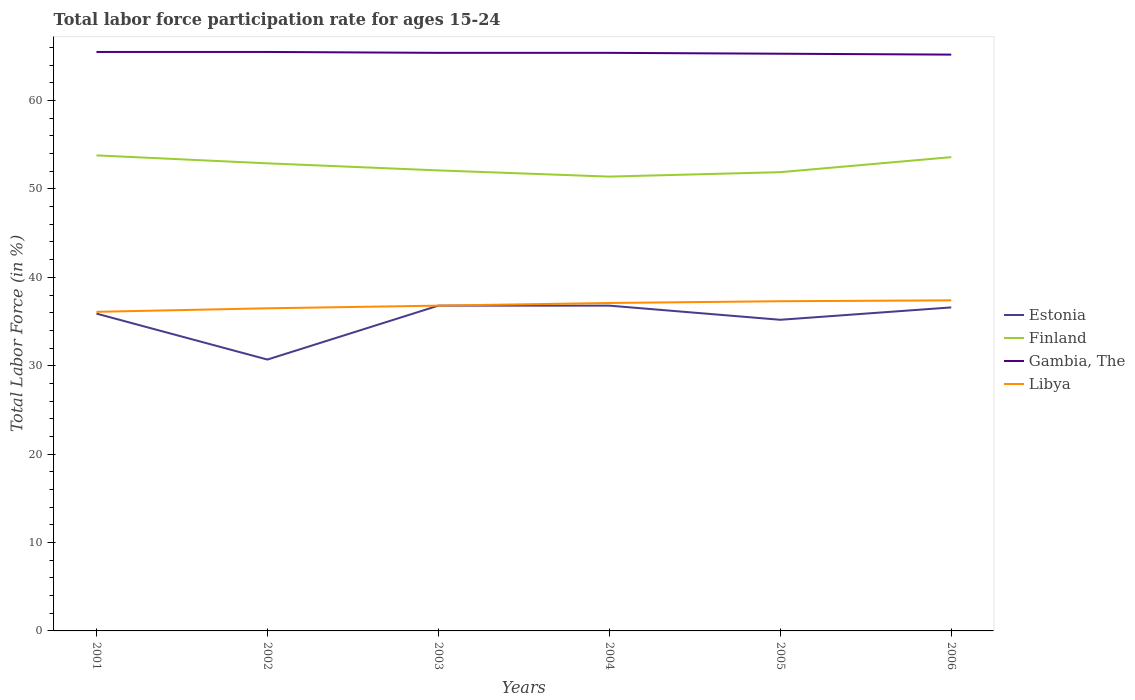Across all years, what is the maximum labor force participation rate in Finland?
Keep it short and to the point. 51.4. What is the total labor force participation rate in Libya in the graph?
Make the answer very short. -1.3. What is the difference between the highest and the second highest labor force participation rate in Estonia?
Give a very brief answer. 6.1. Is the labor force participation rate in Gambia, The strictly greater than the labor force participation rate in Libya over the years?
Your answer should be compact. No. What is the difference between two consecutive major ticks on the Y-axis?
Offer a very short reply. 10. Are the values on the major ticks of Y-axis written in scientific E-notation?
Make the answer very short. No. Does the graph contain grids?
Provide a short and direct response. No. How many legend labels are there?
Provide a short and direct response. 4. What is the title of the graph?
Offer a very short reply. Total labor force participation rate for ages 15-24. Does "Belarus" appear as one of the legend labels in the graph?
Provide a succinct answer. No. What is the label or title of the X-axis?
Your response must be concise. Years. What is the Total Labor Force (in %) in Estonia in 2001?
Provide a short and direct response. 35.9. What is the Total Labor Force (in %) of Finland in 2001?
Your answer should be compact. 53.8. What is the Total Labor Force (in %) of Gambia, The in 2001?
Your answer should be very brief. 65.5. What is the Total Labor Force (in %) of Libya in 2001?
Keep it short and to the point. 36.1. What is the Total Labor Force (in %) in Estonia in 2002?
Give a very brief answer. 30.7. What is the Total Labor Force (in %) in Finland in 2002?
Offer a terse response. 52.9. What is the Total Labor Force (in %) of Gambia, The in 2002?
Offer a very short reply. 65.5. What is the Total Labor Force (in %) of Libya in 2002?
Offer a terse response. 36.5. What is the Total Labor Force (in %) of Estonia in 2003?
Your answer should be compact. 36.8. What is the Total Labor Force (in %) of Finland in 2003?
Provide a short and direct response. 52.1. What is the Total Labor Force (in %) in Gambia, The in 2003?
Make the answer very short. 65.4. What is the Total Labor Force (in %) of Libya in 2003?
Ensure brevity in your answer.  36.8. What is the Total Labor Force (in %) of Estonia in 2004?
Your answer should be compact. 36.8. What is the Total Labor Force (in %) in Finland in 2004?
Provide a short and direct response. 51.4. What is the Total Labor Force (in %) in Gambia, The in 2004?
Ensure brevity in your answer.  65.4. What is the Total Labor Force (in %) in Libya in 2004?
Offer a very short reply. 37.1. What is the Total Labor Force (in %) of Estonia in 2005?
Your answer should be very brief. 35.2. What is the Total Labor Force (in %) of Finland in 2005?
Your answer should be very brief. 51.9. What is the Total Labor Force (in %) in Gambia, The in 2005?
Offer a very short reply. 65.3. What is the Total Labor Force (in %) of Libya in 2005?
Your response must be concise. 37.3. What is the Total Labor Force (in %) of Estonia in 2006?
Give a very brief answer. 36.6. What is the Total Labor Force (in %) in Finland in 2006?
Provide a short and direct response. 53.6. What is the Total Labor Force (in %) of Gambia, The in 2006?
Offer a terse response. 65.2. What is the Total Labor Force (in %) in Libya in 2006?
Provide a short and direct response. 37.4. Across all years, what is the maximum Total Labor Force (in %) of Estonia?
Your answer should be compact. 36.8. Across all years, what is the maximum Total Labor Force (in %) of Finland?
Offer a terse response. 53.8. Across all years, what is the maximum Total Labor Force (in %) in Gambia, The?
Your response must be concise. 65.5. Across all years, what is the maximum Total Labor Force (in %) in Libya?
Ensure brevity in your answer.  37.4. Across all years, what is the minimum Total Labor Force (in %) of Estonia?
Provide a short and direct response. 30.7. Across all years, what is the minimum Total Labor Force (in %) in Finland?
Your response must be concise. 51.4. Across all years, what is the minimum Total Labor Force (in %) in Gambia, The?
Provide a short and direct response. 65.2. Across all years, what is the minimum Total Labor Force (in %) in Libya?
Your response must be concise. 36.1. What is the total Total Labor Force (in %) in Estonia in the graph?
Give a very brief answer. 212. What is the total Total Labor Force (in %) of Finland in the graph?
Offer a terse response. 315.7. What is the total Total Labor Force (in %) in Gambia, The in the graph?
Offer a very short reply. 392.3. What is the total Total Labor Force (in %) in Libya in the graph?
Ensure brevity in your answer.  221.2. What is the difference between the Total Labor Force (in %) in Finland in 2001 and that in 2002?
Give a very brief answer. 0.9. What is the difference between the Total Labor Force (in %) in Libya in 2001 and that in 2003?
Keep it short and to the point. -0.7. What is the difference between the Total Labor Force (in %) in Finland in 2001 and that in 2004?
Offer a very short reply. 2.4. What is the difference between the Total Labor Force (in %) in Gambia, The in 2001 and that in 2004?
Ensure brevity in your answer.  0.1. What is the difference between the Total Labor Force (in %) in Estonia in 2001 and that in 2005?
Provide a succinct answer. 0.7. What is the difference between the Total Labor Force (in %) in Libya in 2001 and that in 2005?
Keep it short and to the point. -1.2. What is the difference between the Total Labor Force (in %) of Estonia in 2001 and that in 2006?
Your answer should be very brief. -0.7. What is the difference between the Total Labor Force (in %) in Gambia, The in 2001 and that in 2006?
Your answer should be very brief. 0.3. What is the difference between the Total Labor Force (in %) of Libya in 2001 and that in 2006?
Your answer should be compact. -1.3. What is the difference between the Total Labor Force (in %) in Estonia in 2002 and that in 2005?
Your answer should be very brief. -4.5. What is the difference between the Total Labor Force (in %) of Gambia, The in 2002 and that in 2005?
Your answer should be compact. 0.2. What is the difference between the Total Labor Force (in %) in Finland in 2002 and that in 2006?
Provide a succinct answer. -0.7. What is the difference between the Total Labor Force (in %) in Gambia, The in 2002 and that in 2006?
Keep it short and to the point. 0.3. What is the difference between the Total Labor Force (in %) in Gambia, The in 2003 and that in 2004?
Make the answer very short. 0. What is the difference between the Total Labor Force (in %) in Libya in 2003 and that in 2004?
Your response must be concise. -0.3. What is the difference between the Total Labor Force (in %) in Libya in 2003 and that in 2005?
Offer a terse response. -0.5. What is the difference between the Total Labor Force (in %) in Finland in 2003 and that in 2006?
Make the answer very short. -1.5. What is the difference between the Total Labor Force (in %) of Finland in 2004 and that in 2005?
Provide a short and direct response. -0.5. What is the difference between the Total Labor Force (in %) in Libya in 2004 and that in 2005?
Your answer should be very brief. -0.2. What is the difference between the Total Labor Force (in %) in Libya in 2004 and that in 2006?
Offer a very short reply. -0.3. What is the difference between the Total Labor Force (in %) in Estonia in 2005 and that in 2006?
Provide a succinct answer. -1.4. What is the difference between the Total Labor Force (in %) in Finland in 2005 and that in 2006?
Give a very brief answer. -1.7. What is the difference between the Total Labor Force (in %) of Gambia, The in 2005 and that in 2006?
Give a very brief answer. 0.1. What is the difference between the Total Labor Force (in %) of Libya in 2005 and that in 2006?
Your answer should be very brief. -0.1. What is the difference between the Total Labor Force (in %) in Estonia in 2001 and the Total Labor Force (in %) in Finland in 2002?
Keep it short and to the point. -17. What is the difference between the Total Labor Force (in %) of Estonia in 2001 and the Total Labor Force (in %) of Gambia, The in 2002?
Give a very brief answer. -29.6. What is the difference between the Total Labor Force (in %) in Estonia in 2001 and the Total Labor Force (in %) in Libya in 2002?
Keep it short and to the point. -0.6. What is the difference between the Total Labor Force (in %) of Estonia in 2001 and the Total Labor Force (in %) of Finland in 2003?
Keep it short and to the point. -16.2. What is the difference between the Total Labor Force (in %) of Estonia in 2001 and the Total Labor Force (in %) of Gambia, The in 2003?
Your answer should be very brief. -29.5. What is the difference between the Total Labor Force (in %) in Estonia in 2001 and the Total Labor Force (in %) in Libya in 2003?
Provide a succinct answer. -0.9. What is the difference between the Total Labor Force (in %) in Finland in 2001 and the Total Labor Force (in %) in Libya in 2003?
Offer a terse response. 17. What is the difference between the Total Labor Force (in %) in Gambia, The in 2001 and the Total Labor Force (in %) in Libya in 2003?
Provide a succinct answer. 28.7. What is the difference between the Total Labor Force (in %) in Estonia in 2001 and the Total Labor Force (in %) in Finland in 2004?
Provide a succinct answer. -15.5. What is the difference between the Total Labor Force (in %) of Estonia in 2001 and the Total Labor Force (in %) of Gambia, The in 2004?
Provide a short and direct response. -29.5. What is the difference between the Total Labor Force (in %) of Estonia in 2001 and the Total Labor Force (in %) of Libya in 2004?
Give a very brief answer. -1.2. What is the difference between the Total Labor Force (in %) of Finland in 2001 and the Total Labor Force (in %) of Gambia, The in 2004?
Keep it short and to the point. -11.6. What is the difference between the Total Labor Force (in %) in Gambia, The in 2001 and the Total Labor Force (in %) in Libya in 2004?
Your response must be concise. 28.4. What is the difference between the Total Labor Force (in %) of Estonia in 2001 and the Total Labor Force (in %) of Finland in 2005?
Make the answer very short. -16. What is the difference between the Total Labor Force (in %) of Estonia in 2001 and the Total Labor Force (in %) of Gambia, The in 2005?
Make the answer very short. -29.4. What is the difference between the Total Labor Force (in %) of Finland in 2001 and the Total Labor Force (in %) of Gambia, The in 2005?
Ensure brevity in your answer.  -11.5. What is the difference between the Total Labor Force (in %) in Gambia, The in 2001 and the Total Labor Force (in %) in Libya in 2005?
Offer a very short reply. 28.2. What is the difference between the Total Labor Force (in %) in Estonia in 2001 and the Total Labor Force (in %) in Finland in 2006?
Provide a succinct answer. -17.7. What is the difference between the Total Labor Force (in %) of Estonia in 2001 and the Total Labor Force (in %) of Gambia, The in 2006?
Provide a succinct answer. -29.3. What is the difference between the Total Labor Force (in %) in Gambia, The in 2001 and the Total Labor Force (in %) in Libya in 2006?
Your answer should be very brief. 28.1. What is the difference between the Total Labor Force (in %) of Estonia in 2002 and the Total Labor Force (in %) of Finland in 2003?
Give a very brief answer. -21.4. What is the difference between the Total Labor Force (in %) in Estonia in 2002 and the Total Labor Force (in %) in Gambia, The in 2003?
Your answer should be very brief. -34.7. What is the difference between the Total Labor Force (in %) of Finland in 2002 and the Total Labor Force (in %) of Gambia, The in 2003?
Your response must be concise. -12.5. What is the difference between the Total Labor Force (in %) in Gambia, The in 2002 and the Total Labor Force (in %) in Libya in 2003?
Provide a succinct answer. 28.7. What is the difference between the Total Labor Force (in %) in Estonia in 2002 and the Total Labor Force (in %) in Finland in 2004?
Make the answer very short. -20.7. What is the difference between the Total Labor Force (in %) of Estonia in 2002 and the Total Labor Force (in %) of Gambia, The in 2004?
Make the answer very short. -34.7. What is the difference between the Total Labor Force (in %) in Gambia, The in 2002 and the Total Labor Force (in %) in Libya in 2004?
Provide a succinct answer. 28.4. What is the difference between the Total Labor Force (in %) in Estonia in 2002 and the Total Labor Force (in %) in Finland in 2005?
Make the answer very short. -21.2. What is the difference between the Total Labor Force (in %) of Estonia in 2002 and the Total Labor Force (in %) of Gambia, The in 2005?
Provide a succinct answer. -34.6. What is the difference between the Total Labor Force (in %) in Estonia in 2002 and the Total Labor Force (in %) in Libya in 2005?
Keep it short and to the point. -6.6. What is the difference between the Total Labor Force (in %) in Gambia, The in 2002 and the Total Labor Force (in %) in Libya in 2005?
Offer a terse response. 28.2. What is the difference between the Total Labor Force (in %) of Estonia in 2002 and the Total Labor Force (in %) of Finland in 2006?
Ensure brevity in your answer.  -22.9. What is the difference between the Total Labor Force (in %) of Estonia in 2002 and the Total Labor Force (in %) of Gambia, The in 2006?
Provide a succinct answer. -34.5. What is the difference between the Total Labor Force (in %) of Finland in 2002 and the Total Labor Force (in %) of Gambia, The in 2006?
Your answer should be compact. -12.3. What is the difference between the Total Labor Force (in %) in Gambia, The in 2002 and the Total Labor Force (in %) in Libya in 2006?
Ensure brevity in your answer.  28.1. What is the difference between the Total Labor Force (in %) in Estonia in 2003 and the Total Labor Force (in %) in Finland in 2004?
Offer a terse response. -14.6. What is the difference between the Total Labor Force (in %) in Estonia in 2003 and the Total Labor Force (in %) in Gambia, The in 2004?
Provide a succinct answer. -28.6. What is the difference between the Total Labor Force (in %) of Finland in 2003 and the Total Labor Force (in %) of Libya in 2004?
Ensure brevity in your answer.  15. What is the difference between the Total Labor Force (in %) of Gambia, The in 2003 and the Total Labor Force (in %) of Libya in 2004?
Offer a very short reply. 28.3. What is the difference between the Total Labor Force (in %) of Estonia in 2003 and the Total Labor Force (in %) of Finland in 2005?
Offer a very short reply. -15.1. What is the difference between the Total Labor Force (in %) of Estonia in 2003 and the Total Labor Force (in %) of Gambia, The in 2005?
Your answer should be compact. -28.5. What is the difference between the Total Labor Force (in %) of Estonia in 2003 and the Total Labor Force (in %) of Libya in 2005?
Ensure brevity in your answer.  -0.5. What is the difference between the Total Labor Force (in %) in Finland in 2003 and the Total Labor Force (in %) in Libya in 2005?
Make the answer very short. 14.8. What is the difference between the Total Labor Force (in %) of Gambia, The in 2003 and the Total Labor Force (in %) of Libya in 2005?
Make the answer very short. 28.1. What is the difference between the Total Labor Force (in %) in Estonia in 2003 and the Total Labor Force (in %) in Finland in 2006?
Offer a terse response. -16.8. What is the difference between the Total Labor Force (in %) in Estonia in 2003 and the Total Labor Force (in %) in Gambia, The in 2006?
Your answer should be compact. -28.4. What is the difference between the Total Labor Force (in %) in Finland in 2003 and the Total Labor Force (in %) in Libya in 2006?
Offer a very short reply. 14.7. What is the difference between the Total Labor Force (in %) in Estonia in 2004 and the Total Labor Force (in %) in Finland in 2005?
Offer a terse response. -15.1. What is the difference between the Total Labor Force (in %) of Estonia in 2004 and the Total Labor Force (in %) of Gambia, The in 2005?
Give a very brief answer. -28.5. What is the difference between the Total Labor Force (in %) in Gambia, The in 2004 and the Total Labor Force (in %) in Libya in 2005?
Provide a succinct answer. 28.1. What is the difference between the Total Labor Force (in %) of Estonia in 2004 and the Total Labor Force (in %) of Finland in 2006?
Make the answer very short. -16.8. What is the difference between the Total Labor Force (in %) of Estonia in 2004 and the Total Labor Force (in %) of Gambia, The in 2006?
Make the answer very short. -28.4. What is the difference between the Total Labor Force (in %) in Estonia in 2004 and the Total Labor Force (in %) in Libya in 2006?
Give a very brief answer. -0.6. What is the difference between the Total Labor Force (in %) in Finland in 2004 and the Total Labor Force (in %) in Gambia, The in 2006?
Offer a terse response. -13.8. What is the difference between the Total Labor Force (in %) of Finland in 2004 and the Total Labor Force (in %) of Libya in 2006?
Your answer should be compact. 14. What is the difference between the Total Labor Force (in %) of Estonia in 2005 and the Total Labor Force (in %) of Finland in 2006?
Make the answer very short. -18.4. What is the difference between the Total Labor Force (in %) of Estonia in 2005 and the Total Labor Force (in %) of Gambia, The in 2006?
Offer a very short reply. -30. What is the difference between the Total Labor Force (in %) in Finland in 2005 and the Total Labor Force (in %) in Gambia, The in 2006?
Your answer should be very brief. -13.3. What is the difference between the Total Labor Force (in %) in Gambia, The in 2005 and the Total Labor Force (in %) in Libya in 2006?
Offer a very short reply. 27.9. What is the average Total Labor Force (in %) in Estonia per year?
Your answer should be very brief. 35.33. What is the average Total Labor Force (in %) in Finland per year?
Offer a very short reply. 52.62. What is the average Total Labor Force (in %) in Gambia, The per year?
Give a very brief answer. 65.38. What is the average Total Labor Force (in %) in Libya per year?
Offer a terse response. 36.87. In the year 2001, what is the difference between the Total Labor Force (in %) of Estonia and Total Labor Force (in %) of Finland?
Provide a short and direct response. -17.9. In the year 2001, what is the difference between the Total Labor Force (in %) of Estonia and Total Labor Force (in %) of Gambia, The?
Your answer should be very brief. -29.6. In the year 2001, what is the difference between the Total Labor Force (in %) of Finland and Total Labor Force (in %) of Libya?
Give a very brief answer. 17.7. In the year 2001, what is the difference between the Total Labor Force (in %) in Gambia, The and Total Labor Force (in %) in Libya?
Provide a short and direct response. 29.4. In the year 2002, what is the difference between the Total Labor Force (in %) in Estonia and Total Labor Force (in %) in Finland?
Give a very brief answer. -22.2. In the year 2002, what is the difference between the Total Labor Force (in %) of Estonia and Total Labor Force (in %) of Gambia, The?
Your answer should be compact. -34.8. In the year 2002, what is the difference between the Total Labor Force (in %) in Estonia and Total Labor Force (in %) in Libya?
Offer a very short reply. -5.8. In the year 2002, what is the difference between the Total Labor Force (in %) in Finland and Total Labor Force (in %) in Libya?
Provide a succinct answer. 16.4. In the year 2002, what is the difference between the Total Labor Force (in %) of Gambia, The and Total Labor Force (in %) of Libya?
Ensure brevity in your answer.  29. In the year 2003, what is the difference between the Total Labor Force (in %) in Estonia and Total Labor Force (in %) in Finland?
Offer a terse response. -15.3. In the year 2003, what is the difference between the Total Labor Force (in %) in Estonia and Total Labor Force (in %) in Gambia, The?
Keep it short and to the point. -28.6. In the year 2003, what is the difference between the Total Labor Force (in %) in Gambia, The and Total Labor Force (in %) in Libya?
Your response must be concise. 28.6. In the year 2004, what is the difference between the Total Labor Force (in %) of Estonia and Total Labor Force (in %) of Finland?
Provide a short and direct response. -14.6. In the year 2004, what is the difference between the Total Labor Force (in %) in Estonia and Total Labor Force (in %) in Gambia, The?
Provide a succinct answer. -28.6. In the year 2004, what is the difference between the Total Labor Force (in %) in Finland and Total Labor Force (in %) in Gambia, The?
Keep it short and to the point. -14. In the year 2004, what is the difference between the Total Labor Force (in %) in Gambia, The and Total Labor Force (in %) in Libya?
Offer a terse response. 28.3. In the year 2005, what is the difference between the Total Labor Force (in %) of Estonia and Total Labor Force (in %) of Finland?
Offer a terse response. -16.7. In the year 2005, what is the difference between the Total Labor Force (in %) of Estonia and Total Labor Force (in %) of Gambia, The?
Offer a terse response. -30.1. In the year 2005, what is the difference between the Total Labor Force (in %) of Estonia and Total Labor Force (in %) of Libya?
Offer a very short reply. -2.1. In the year 2005, what is the difference between the Total Labor Force (in %) of Finland and Total Labor Force (in %) of Gambia, The?
Your response must be concise. -13.4. In the year 2005, what is the difference between the Total Labor Force (in %) of Finland and Total Labor Force (in %) of Libya?
Ensure brevity in your answer.  14.6. In the year 2006, what is the difference between the Total Labor Force (in %) of Estonia and Total Labor Force (in %) of Gambia, The?
Provide a succinct answer. -28.6. In the year 2006, what is the difference between the Total Labor Force (in %) in Finland and Total Labor Force (in %) in Gambia, The?
Ensure brevity in your answer.  -11.6. In the year 2006, what is the difference between the Total Labor Force (in %) in Gambia, The and Total Labor Force (in %) in Libya?
Provide a succinct answer. 27.8. What is the ratio of the Total Labor Force (in %) of Estonia in 2001 to that in 2002?
Make the answer very short. 1.17. What is the ratio of the Total Labor Force (in %) in Finland in 2001 to that in 2002?
Provide a succinct answer. 1.02. What is the ratio of the Total Labor Force (in %) in Gambia, The in 2001 to that in 2002?
Give a very brief answer. 1. What is the ratio of the Total Labor Force (in %) of Libya in 2001 to that in 2002?
Your answer should be compact. 0.99. What is the ratio of the Total Labor Force (in %) of Estonia in 2001 to that in 2003?
Keep it short and to the point. 0.98. What is the ratio of the Total Labor Force (in %) of Finland in 2001 to that in 2003?
Provide a succinct answer. 1.03. What is the ratio of the Total Labor Force (in %) of Gambia, The in 2001 to that in 2003?
Offer a terse response. 1. What is the ratio of the Total Labor Force (in %) in Estonia in 2001 to that in 2004?
Your response must be concise. 0.98. What is the ratio of the Total Labor Force (in %) in Finland in 2001 to that in 2004?
Your answer should be very brief. 1.05. What is the ratio of the Total Labor Force (in %) in Libya in 2001 to that in 2004?
Your answer should be very brief. 0.97. What is the ratio of the Total Labor Force (in %) in Estonia in 2001 to that in 2005?
Your answer should be very brief. 1.02. What is the ratio of the Total Labor Force (in %) in Finland in 2001 to that in 2005?
Your answer should be very brief. 1.04. What is the ratio of the Total Labor Force (in %) in Gambia, The in 2001 to that in 2005?
Provide a short and direct response. 1. What is the ratio of the Total Labor Force (in %) in Libya in 2001 to that in 2005?
Ensure brevity in your answer.  0.97. What is the ratio of the Total Labor Force (in %) of Estonia in 2001 to that in 2006?
Make the answer very short. 0.98. What is the ratio of the Total Labor Force (in %) in Finland in 2001 to that in 2006?
Your answer should be very brief. 1. What is the ratio of the Total Labor Force (in %) in Libya in 2001 to that in 2006?
Provide a short and direct response. 0.97. What is the ratio of the Total Labor Force (in %) of Estonia in 2002 to that in 2003?
Ensure brevity in your answer.  0.83. What is the ratio of the Total Labor Force (in %) in Finland in 2002 to that in 2003?
Your response must be concise. 1.02. What is the ratio of the Total Labor Force (in %) in Estonia in 2002 to that in 2004?
Your answer should be very brief. 0.83. What is the ratio of the Total Labor Force (in %) of Finland in 2002 to that in 2004?
Your response must be concise. 1.03. What is the ratio of the Total Labor Force (in %) in Libya in 2002 to that in 2004?
Offer a terse response. 0.98. What is the ratio of the Total Labor Force (in %) of Estonia in 2002 to that in 2005?
Offer a terse response. 0.87. What is the ratio of the Total Labor Force (in %) in Finland in 2002 to that in 2005?
Provide a short and direct response. 1.02. What is the ratio of the Total Labor Force (in %) in Libya in 2002 to that in 2005?
Keep it short and to the point. 0.98. What is the ratio of the Total Labor Force (in %) of Estonia in 2002 to that in 2006?
Offer a terse response. 0.84. What is the ratio of the Total Labor Force (in %) in Finland in 2002 to that in 2006?
Offer a terse response. 0.99. What is the ratio of the Total Labor Force (in %) of Gambia, The in 2002 to that in 2006?
Make the answer very short. 1. What is the ratio of the Total Labor Force (in %) of Libya in 2002 to that in 2006?
Ensure brevity in your answer.  0.98. What is the ratio of the Total Labor Force (in %) in Finland in 2003 to that in 2004?
Ensure brevity in your answer.  1.01. What is the ratio of the Total Labor Force (in %) of Libya in 2003 to that in 2004?
Your answer should be compact. 0.99. What is the ratio of the Total Labor Force (in %) in Estonia in 2003 to that in 2005?
Ensure brevity in your answer.  1.05. What is the ratio of the Total Labor Force (in %) of Finland in 2003 to that in 2005?
Your answer should be very brief. 1. What is the ratio of the Total Labor Force (in %) in Gambia, The in 2003 to that in 2005?
Your response must be concise. 1. What is the ratio of the Total Labor Force (in %) of Libya in 2003 to that in 2005?
Provide a short and direct response. 0.99. What is the ratio of the Total Labor Force (in %) of Estonia in 2003 to that in 2006?
Provide a short and direct response. 1.01. What is the ratio of the Total Labor Force (in %) of Estonia in 2004 to that in 2005?
Give a very brief answer. 1.05. What is the ratio of the Total Labor Force (in %) of Libya in 2004 to that in 2006?
Make the answer very short. 0.99. What is the ratio of the Total Labor Force (in %) in Estonia in 2005 to that in 2006?
Give a very brief answer. 0.96. What is the ratio of the Total Labor Force (in %) of Finland in 2005 to that in 2006?
Make the answer very short. 0.97. What is the ratio of the Total Labor Force (in %) in Gambia, The in 2005 to that in 2006?
Keep it short and to the point. 1. What is the ratio of the Total Labor Force (in %) in Libya in 2005 to that in 2006?
Make the answer very short. 1. What is the difference between the highest and the second highest Total Labor Force (in %) in Estonia?
Offer a very short reply. 0. What is the difference between the highest and the second highest Total Labor Force (in %) in Finland?
Make the answer very short. 0.2. What is the difference between the highest and the lowest Total Labor Force (in %) of Finland?
Offer a terse response. 2.4. What is the difference between the highest and the lowest Total Labor Force (in %) in Gambia, The?
Ensure brevity in your answer.  0.3. 